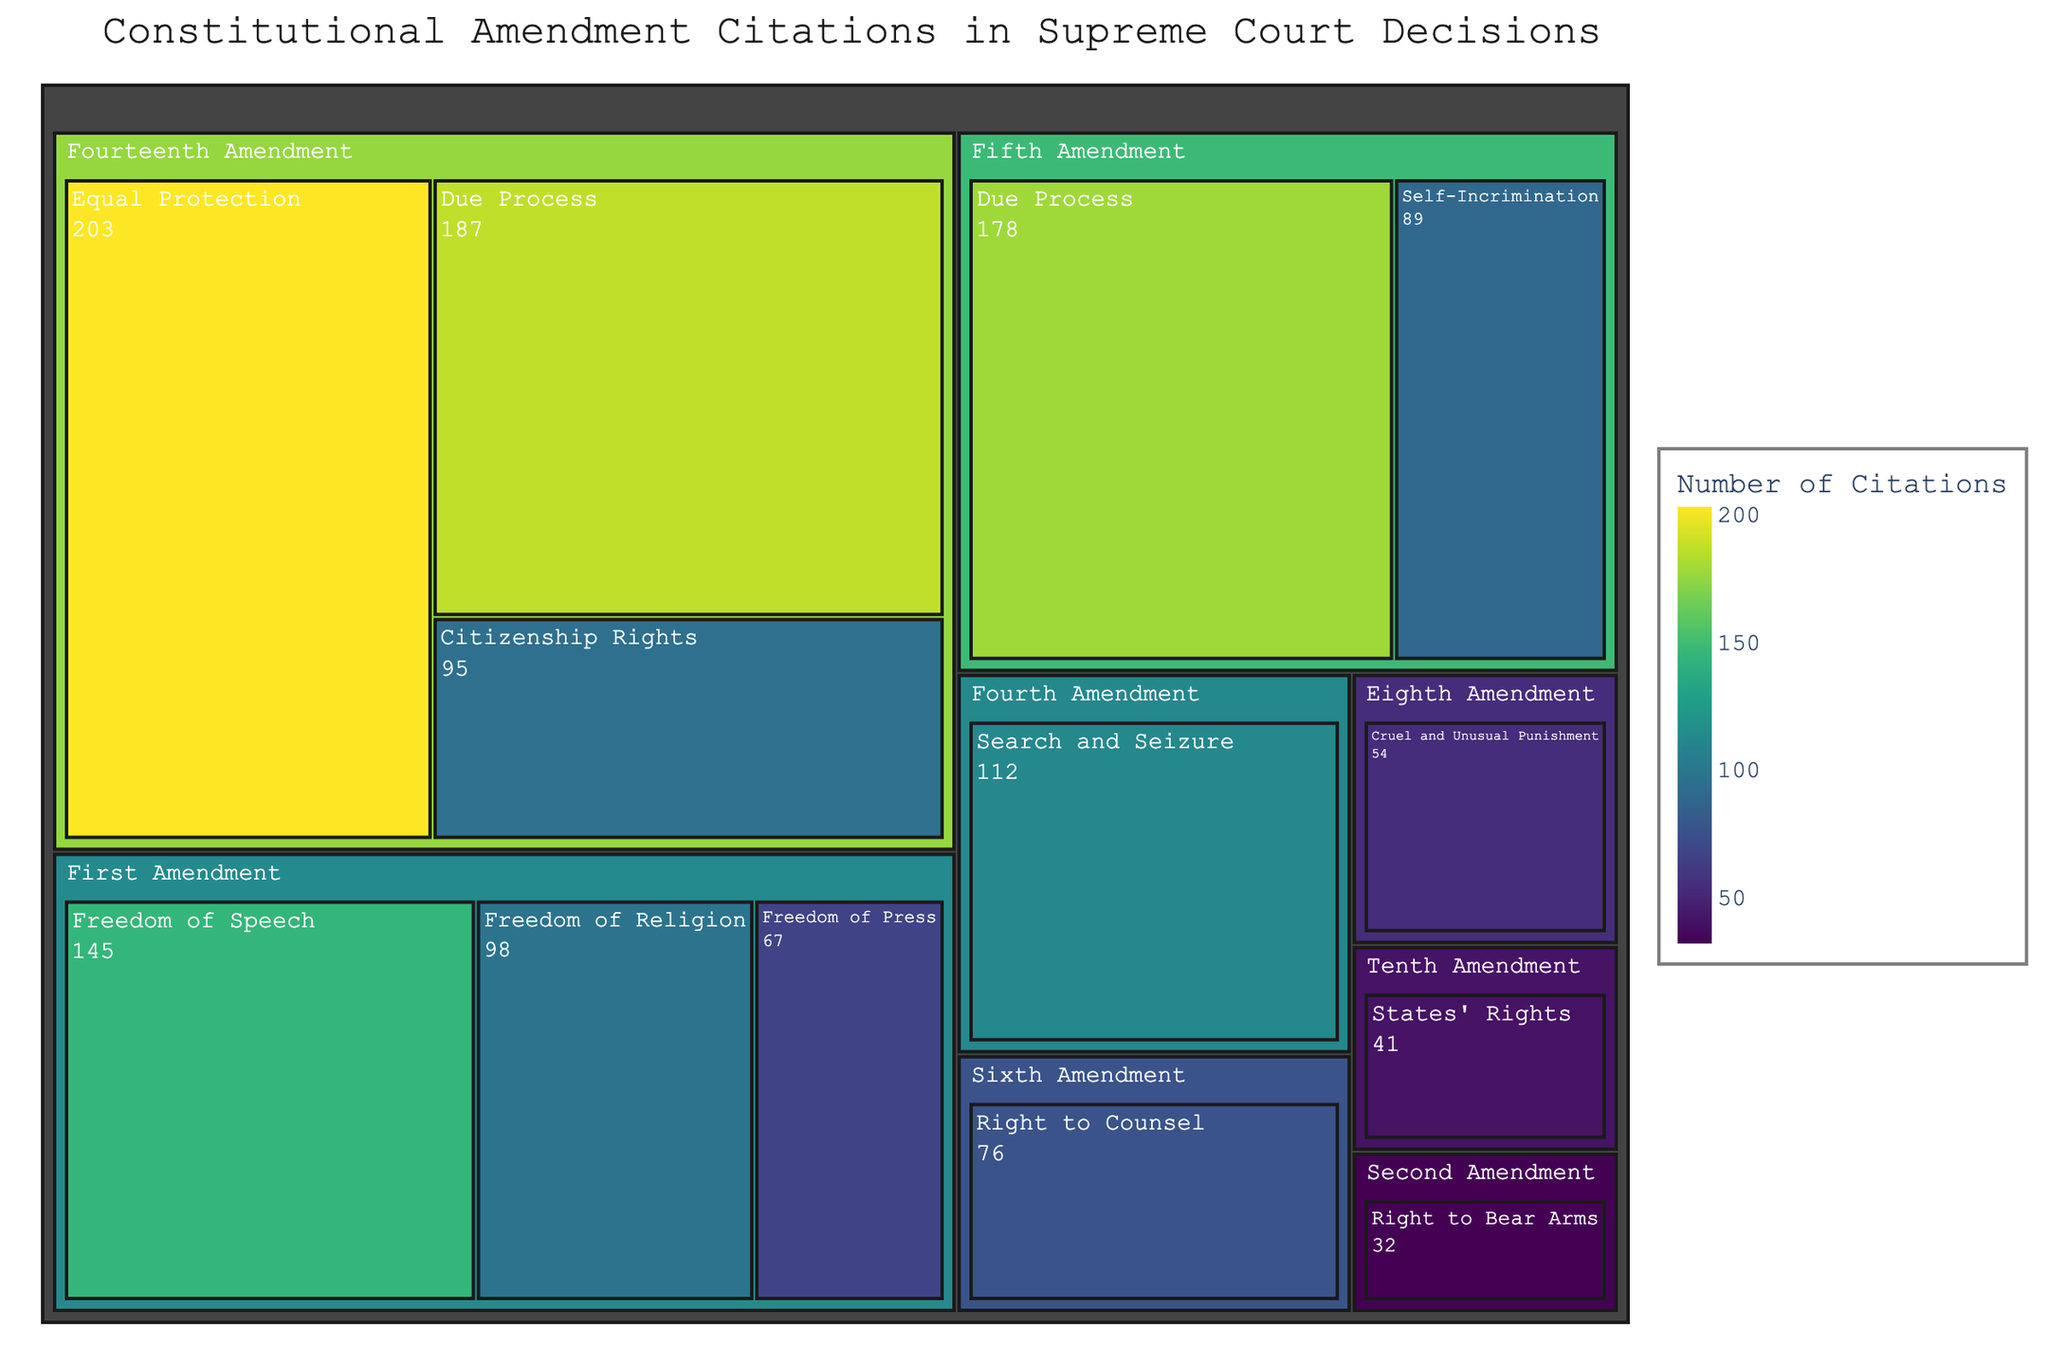What is the title of the treemap? The title is displayed at the top of the treemap and provides an overview of the content being represented.
Answer: Constitutional Amendment Citations in Supreme Court Decisions Which amendment category has the highest number of citations? Look for the largest colored area in the treemap that represents the category with the highest value.
Answer: Fourteenth Amendment, Equal Protection What is the combined number of citations for the First Amendment categories? Sum the values associated with all categories under the First Amendment. (145 + 98 + 67)
Answer: 310 How does the number of citations for the Second Amendment compare to the Third Amendment? Assess the specific areas in the treemap corresponding to each amendment and compare their citation values. The Third Amendment is not represented in the data, only the Second Amendment is cited.
Answer: The Second Amendment has 32 citations, while the Third Amendment has none What is the most cited category under the Fifth Amendment? Look for the category with the largest value listed under the Fifth Amendment.
Answer: Due Process Which amendment has the least number of citations? Identify the smallest area in the treemap which represents the amendment with the lowest citation count.
Answer: Second Amendment What is the difference in citations between the Fourth Amendment and the Eighth Amendment? Subtract the smaller citation number from the larger citation number between the Fourth and Eighth Amendments. (112 - 54)
Answer: 58 Which categories are included under the Fourteenth Amendment? Identify all the categories listed under the Fourteenth Amendment in the treemap.
Answer: Equal Protection, Due Process, Citizenship Rights Compare the number of citations between the categories 'Freedom of Speech' and 'Right to Counsel'. Locate both categories in the treemap and compare their values. Freedom of Speech has 145 citations and Right to Counsel has 76 citations.
Answer: Freedom of Speech has more citations (145) than Right to Counsel (76) What are the total citations for all Due Process categories across different amendments? Sum the citations for all instances of Due Process across different amendments in the treemap (178 for Fifth Amendment + 187 for Fourteenth Amendment).
Answer: 365 